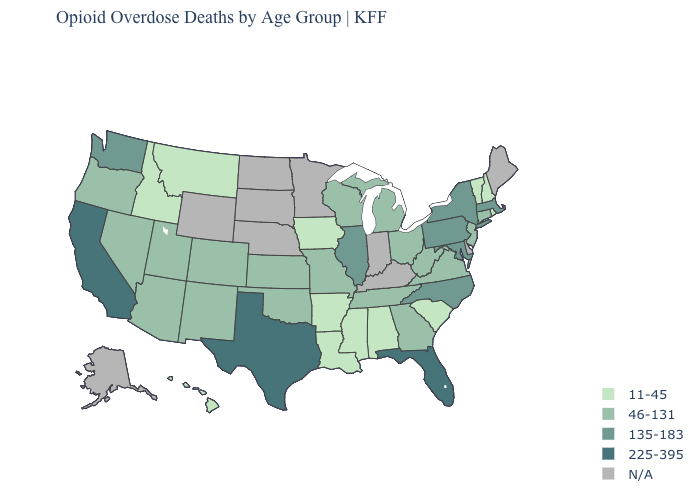Name the states that have a value in the range N/A?
Be succinct. Alaska, Delaware, Indiana, Kentucky, Maine, Minnesota, Nebraska, North Dakota, South Dakota, Wyoming. Among the states that border Alabama , which have the highest value?
Quick response, please. Florida. What is the value of Florida?
Concise answer only. 225-395. What is the highest value in the USA?
Quick response, please. 225-395. Does Virginia have the lowest value in the USA?
Concise answer only. No. Among the states that border Connecticut , which have the highest value?
Answer briefly. Massachusetts, New York. What is the value of New Hampshire?
Answer briefly. 11-45. Which states have the lowest value in the USA?
Quick response, please. Alabama, Arkansas, Hawaii, Idaho, Iowa, Louisiana, Mississippi, Montana, New Hampshire, Rhode Island, South Carolina, Vermont. Which states have the lowest value in the Northeast?
Write a very short answer. New Hampshire, Rhode Island, Vermont. What is the value of West Virginia?
Answer briefly. 46-131. Name the states that have a value in the range 135-183?
Keep it brief. Illinois, Maryland, Massachusetts, New York, North Carolina, Pennsylvania, Washington. Name the states that have a value in the range 135-183?
Write a very short answer. Illinois, Maryland, Massachusetts, New York, North Carolina, Pennsylvania, Washington. Which states have the highest value in the USA?
Short answer required. California, Florida, Texas. Which states have the highest value in the USA?
Concise answer only. California, Florida, Texas. 